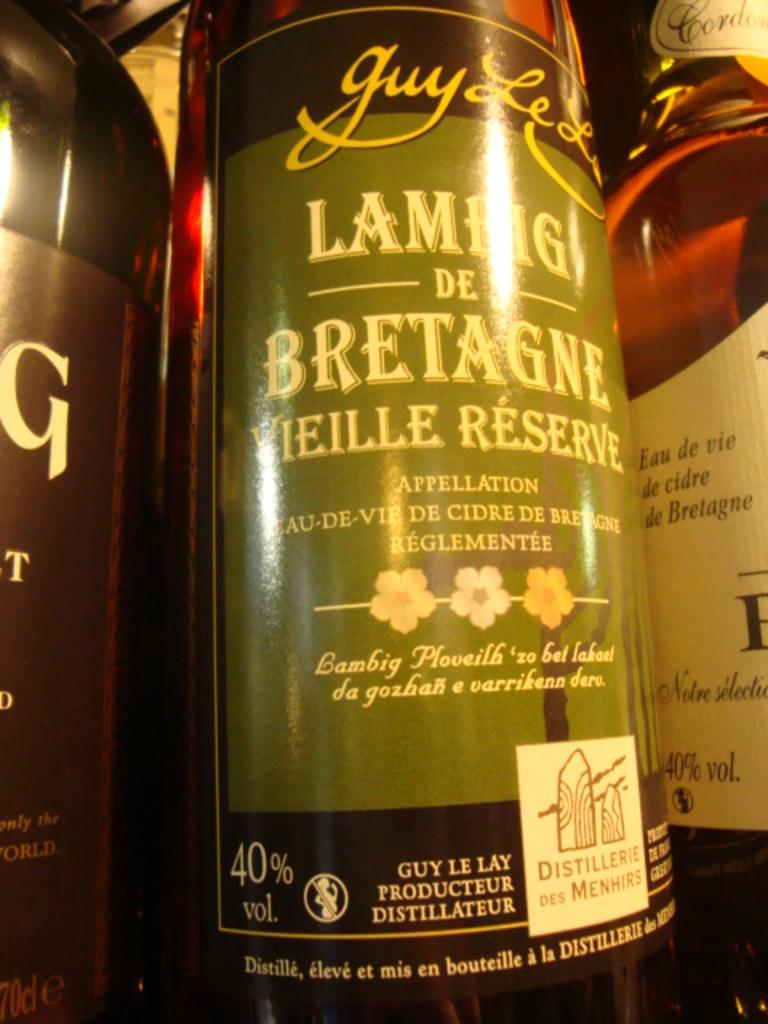<image>
Describe the image concisely. A bottle of Guy Le Lay Vieille Reserve appellation. 